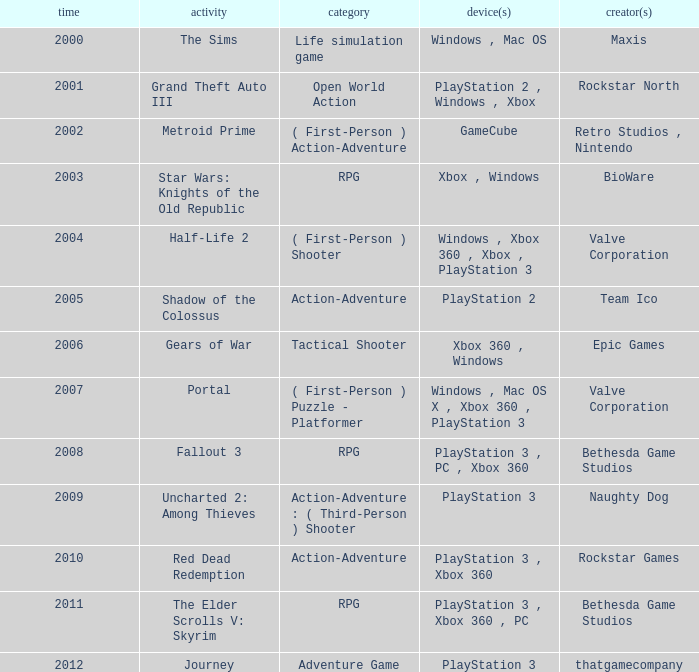What game was in 2011? The Elder Scrolls V: Skyrim. 